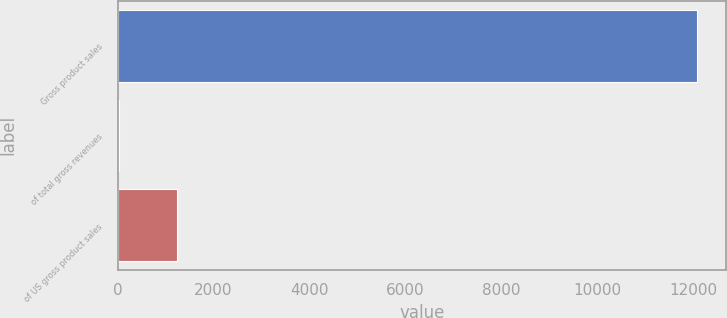Convert chart to OTSL. <chart><loc_0><loc_0><loc_500><loc_500><bar_chart><fcel>Gross product sales<fcel>of total gross revenues<fcel>of US gross product sales<nl><fcel>12091<fcel>33<fcel>1238.8<nl></chart> 